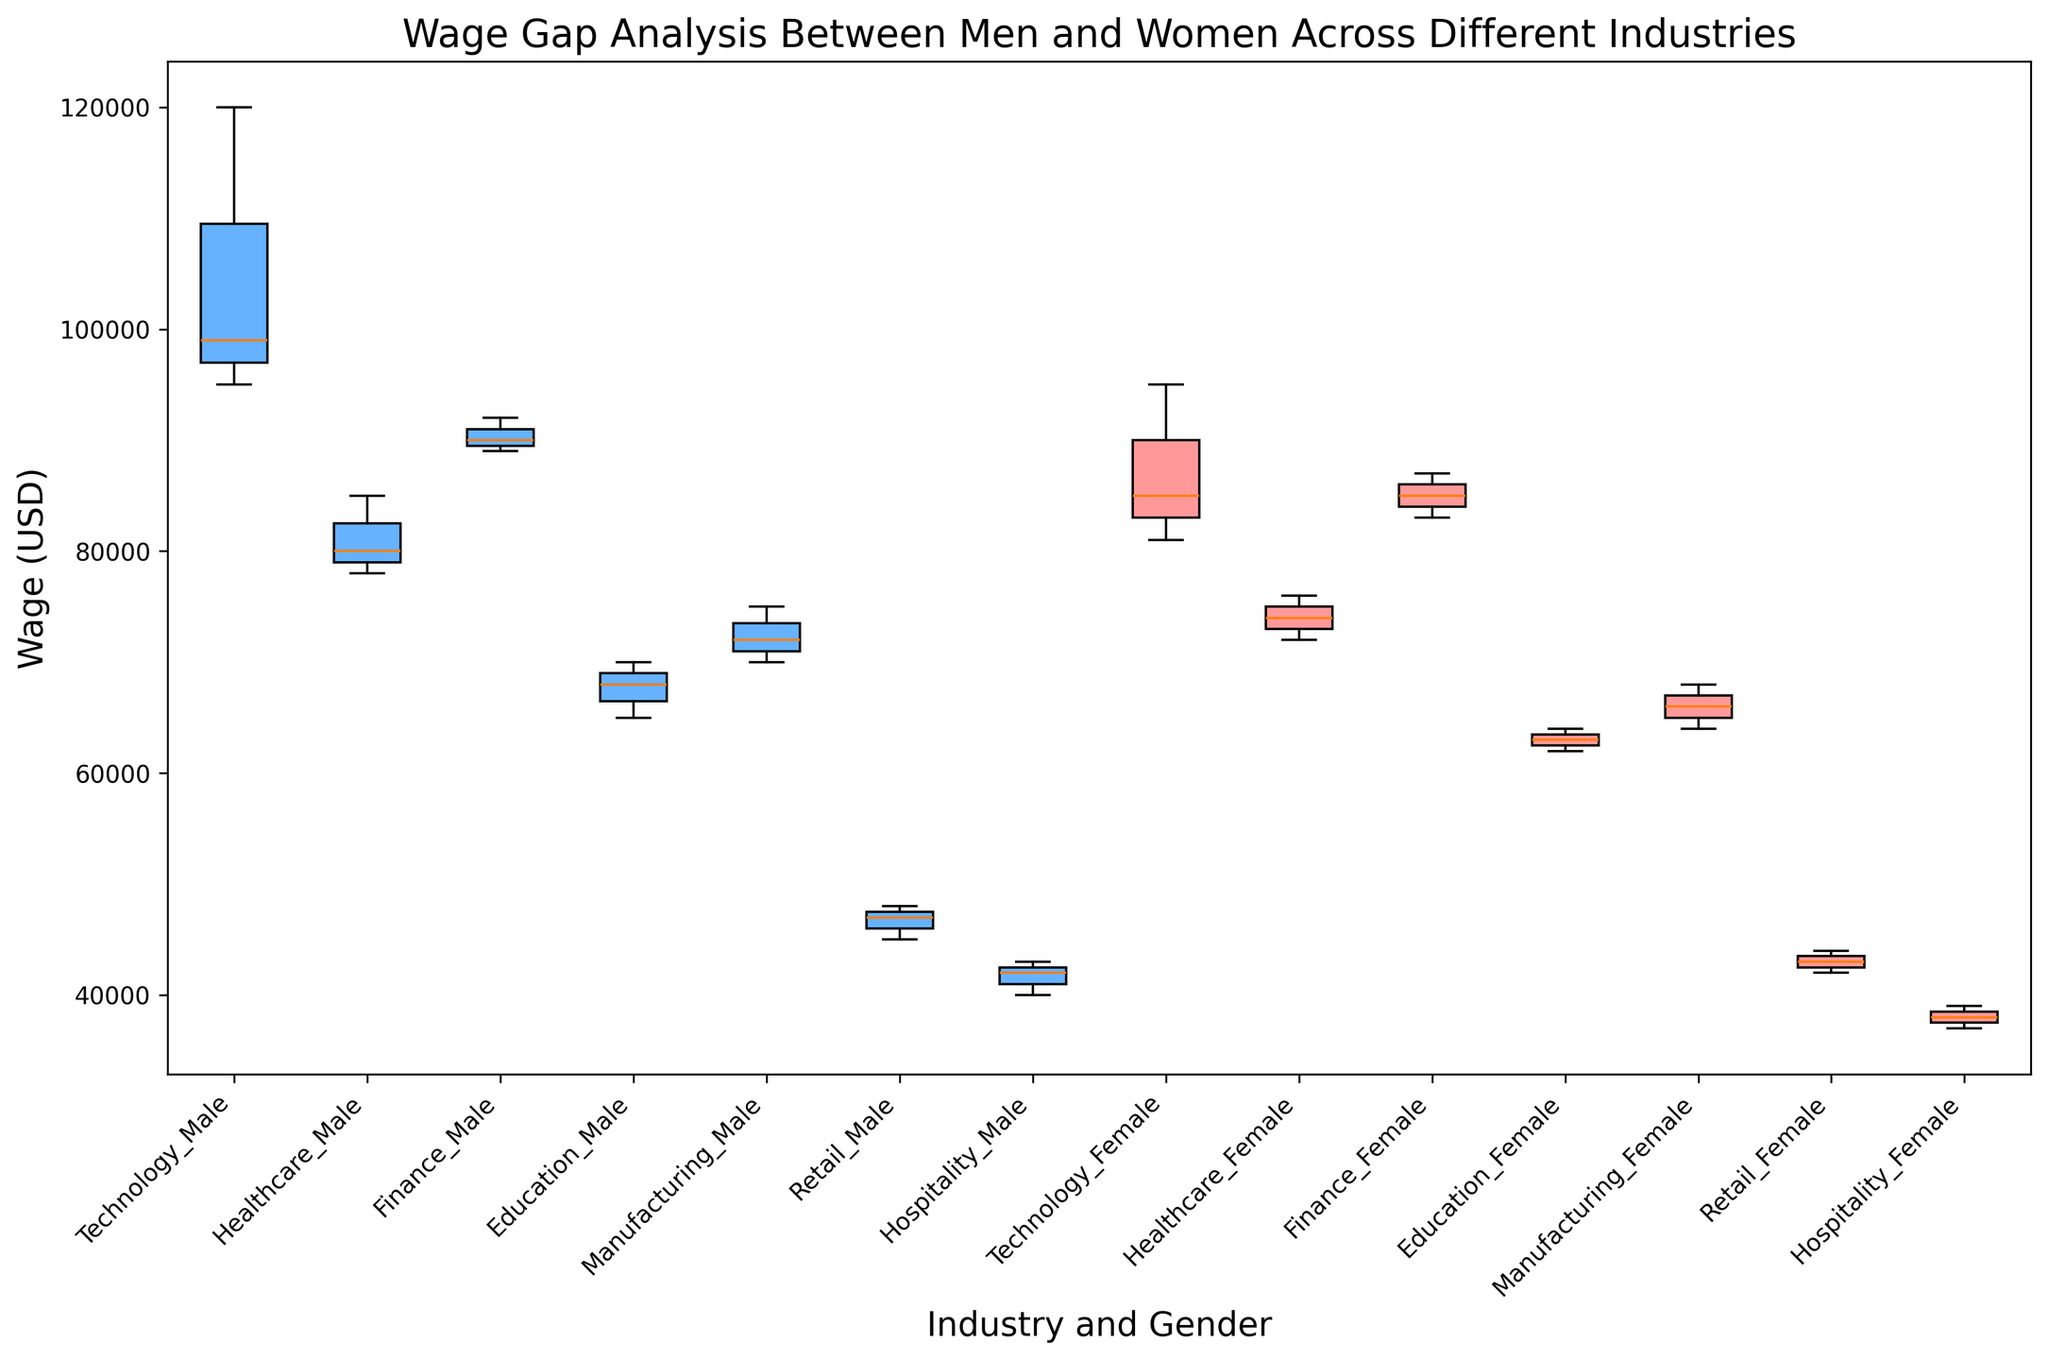What is the median wage for women in the Technology industry? Look for the box labeled "Technology_Female," identify the middle line (median) of the box. The label on the y-axis provides the corresponding wage.
Answer: 85000 Which industry has the largest wage gap between men and women? Compare the distance between the medians of male and female wages for each industry by looking at the middle lines of the corresponding boxes. The Technology industry has the largest gap.
Answer: Technology Are male wages in the Healthcare industry higher on average than female wages in the Education industry? Check the position of the middle line (median) for "Healthcare_Male" and "Education_Female". If the line for Healthcare_Male is higher on the y-axis than Education_Female, then the average is likely higher.
Answer: Yes Which industry shows the closest median wages between men and women? Identify the pairs of male and female boxes and compare the distances between their medians. The Finance industry shows the closest median wages.
Answer: Finance In which industry do men have the highest wages? Look for the highest median line among the male boxes in all industries. The Technology industry has the highest median wage for men.
Answer: Technology Are the wages for women in the Retail industry lower than those for women in Manufacturing? Compare the median lines for "Retail_Female" and "Manufacturing_Female". The median for Retail_Female is lower on the y-axis.
Answer: Yes What is the approximate wage range for men in the Hospitality industry? Look at the "Hospitality_Male" box and note the positions of the bottom and top whiskers (minimum and maximum wages). The whiskers indicate the wage range.
Answer: 40000 to 43000 Do men in the Manufacturing industry have higher wages than men in the Education industry? Compare the median lines for "Manufacturing_Male" and "Education_Male". The median for Manufacturing_Male is higher on the y-axis.
Answer: Yes Which gender has a wider wage range in the Healthcare industry? Compare the lengths of the whiskers (indicating range from minimum to maximum wage) for "Healthcare_Male" and "Healthcare_Female". The whiskers for Healthcare_Female are longer.
Answer: Women 